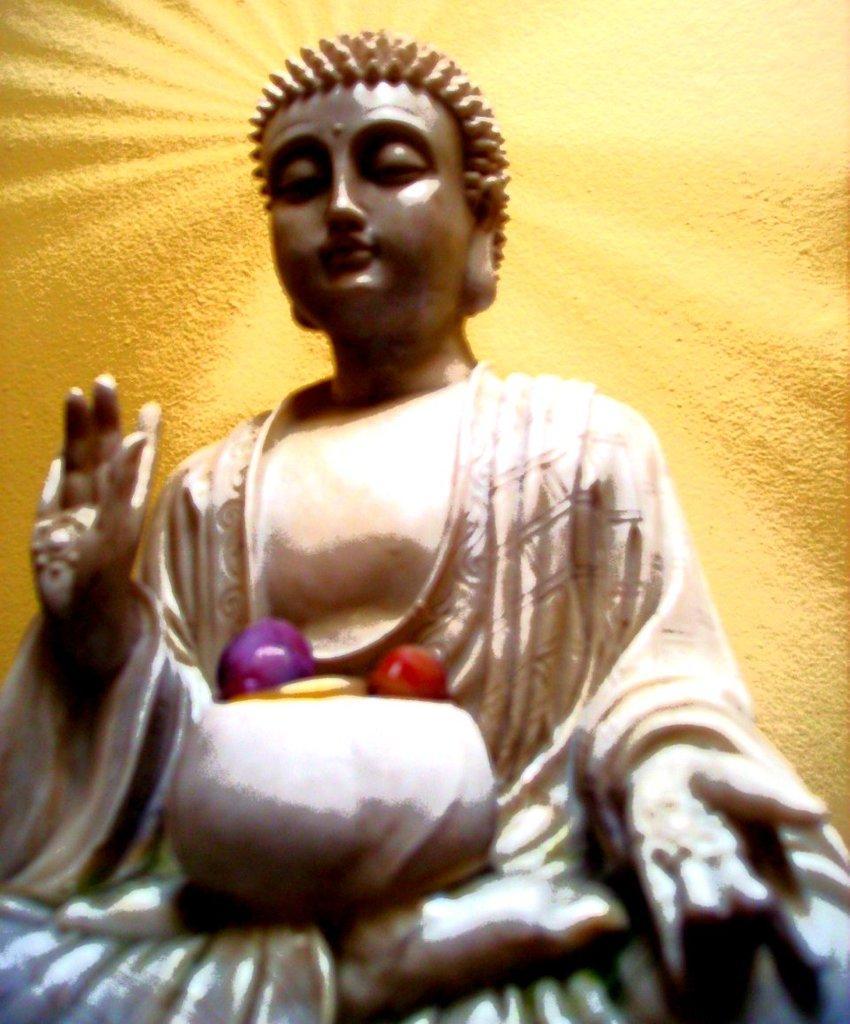In one or two sentences, can you explain what this image depicts? In this image, we can see a statue. Background there is a yellow color. 